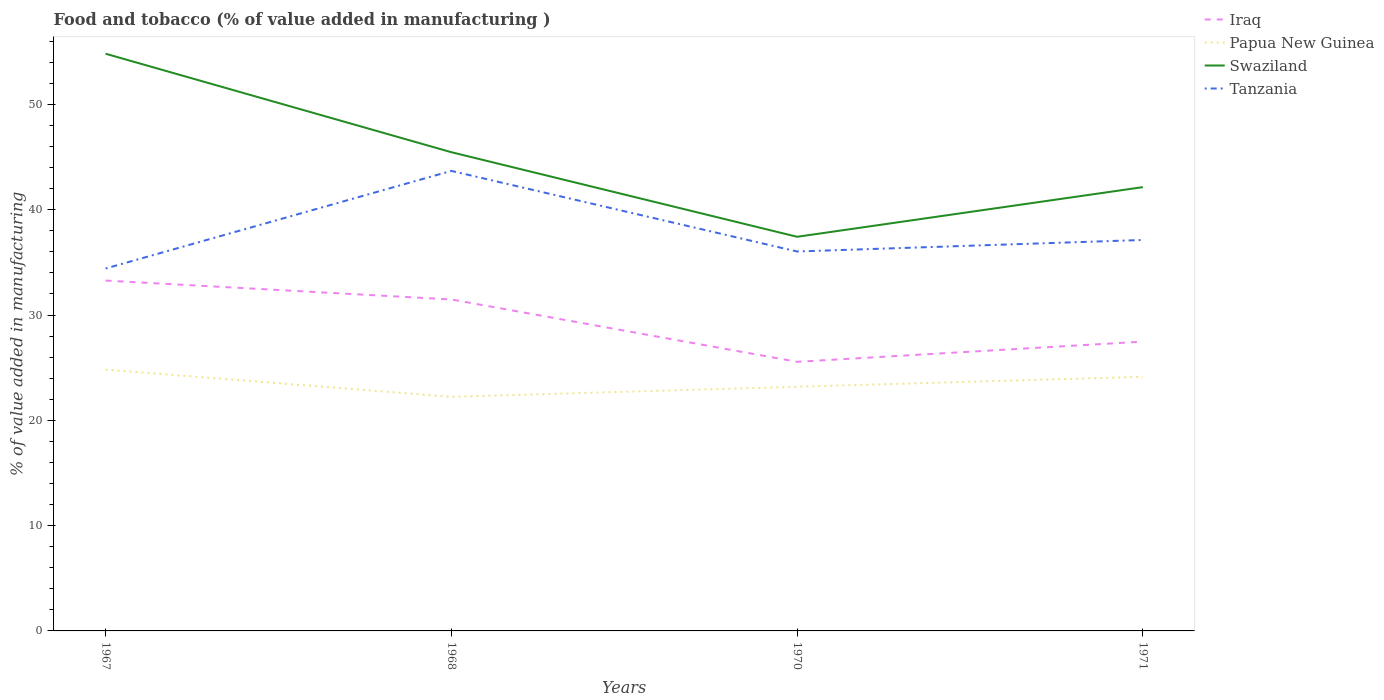How many different coloured lines are there?
Your answer should be compact. 4. Does the line corresponding to Swaziland intersect with the line corresponding to Iraq?
Offer a terse response. No. Across all years, what is the maximum value added in manufacturing food and tobacco in Papua New Guinea?
Provide a succinct answer. 22.23. What is the total value added in manufacturing food and tobacco in Papua New Guinea in the graph?
Your answer should be very brief. -0.96. What is the difference between the highest and the second highest value added in manufacturing food and tobacco in Swaziland?
Provide a short and direct response. 17.39. How many years are there in the graph?
Provide a succinct answer. 4. Are the values on the major ticks of Y-axis written in scientific E-notation?
Your response must be concise. No. Where does the legend appear in the graph?
Provide a succinct answer. Top right. How are the legend labels stacked?
Your answer should be compact. Vertical. What is the title of the graph?
Offer a terse response. Food and tobacco (% of value added in manufacturing ). Does "Puerto Rico" appear as one of the legend labels in the graph?
Your response must be concise. No. What is the label or title of the X-axis?
Ensure brevity in your answer.  Years. What is the label or title of the Y-axis?
Ensure brevity in your answer.  % of value added in manufacturing. What is the % of value added in manufacturing in Iraq in 1967?
Your answer should be very brief. 33.27. What is the % of value added in manufacturing of Papua New Guinea in 1967?
Keep it short and to the point. 24.82. What is the % of value added in manufacturing of Swaziland in 1967?
Your response must be concise. 54.82. What is the % of value added in manufacturing of Tanzania in 1967?
Give a very brief answer. 34.42. What is the % of value added in manufacturing of Iraq in 1968?
Offer a very short reply. 31.48. What is the % of value added in manufacturing of Papua New Guinea in 1968?
Give a very brief answer. 22.23. What is the % of value added in manufacturing of Swaziland in 1968?
Make the answer very short. 45.47. What is the % of value added in manufacturing in Tanzania in 1968?
Offer a terse response. 43.69. What is the % of value added in manufacturing of Iraq in 1970?
Your response must be concise. 25.56. What is the % of value added in manufacturing of Papua New Guinea in 1970?
Your answer should be compact. 23.19. What is the % of value added in manufacturing in Swaziland in 1970?
Your answer should be very brief. 37.43. What is the % of value added in manufacturing in Tanzania in 1970?
Your answer should be very brief. 36.04. What is the % of value added in manufacturing in Iraq in 1971?
Your answer should be compact. 27.48. What is the % of value added in manufacturing in Papua New Guinea in 1971?
Ensure brevity in your answer.  24.13. What is the % of value added in manufacturing of Swaziland in 1971?
Make the answer very short. 42.15. What is the % of value added in manufacturing in Tanzania in 1971?
Provide a short and direct response. 37.13. Across all years, what is the maximum % of value added in manufacturing in Iraq?
Make the answer very short. 33.27. Across all years, what is the maximum % of value added in manufacturing of Papua New Guinea?
Your answer should be very brief. 24.82. Across all years, what is the maximum % of value added in manufacturing of Swaziland?
Give a very brief answer. 54.82. Across all years, what is the maximum % of value added in manufacturing in Tanzania?
Provide a short and direct response. 43.69. Across all years, what is the minimum % of value added in manufacturing of Iraq?
Keep it short and to the point. 25.56. Across all years, what is the minimum % of value added in manufacturing of Papua New Guinea?
Your answer should be compact. 22.23. Across all years, what is the minimum % of value added in manufacturing in Swaziland?
Your response must be concise. 37.43. Across all years, what is the minimum % of value added in manufacturing of Tanzania?
Keep it short and to the point. 34.42. What is the total % of value added in manufacturing in Iraq in the graph?
Offer a very short reply. 117.79. What is the total % of value added in manufacturing of Papua New Guinea in the graph?
Provide a succinct answer. 94.37. What is the total % of value added in manufacturing of Swaziland in the graph?
Offer a terse response. 179.86. What is the total % of value added in manufacturing of Tanzania in the graph?
Keep it short and to the point. 151.27. What is the difference between the % of value added in manufacturing of Iraq in 1967 and that in 1968?
Offer a terse response. 1.79. What is the difference between the % of value added in manufacturing in Papua New Guinea in 1967 and that in 1968?
Offer a terse response. 2.59. What is the difference between the % of value added in manufacturing in Swaziland in 1967 and that in 1968?
Your answer should be compact. 9.35. What is the difference between the % of value added in manufacturing of Tanzania in 1967 and that in 1968?
Offer a terse response. -9.27. What is the difference between the % of value added in manufacturing of Iraq in 1967 and that in 1970?
Give a very brief answer. 7.72. What is the difference between the % of value added in manufacturing in Papua New Guinea in 1967 and that in 1970?
Make the answer very short. 1.63. What is the difference between the % of value added in manufacturing in Swaziland in 1967 and that in 1970?
Your response must be concise. 17.39. What is the difference between the % of value added in manufacturing in Tanzania in 1967 and that in 1970?
Give a very brief answer. -1.62. What is the difference between the % of value added in manufacturing in Iraq in 1967 and that in 1971?
Your answer should be very brief. 5.8. What is the difference between the % of value added in manufacturing of Papua New Guinea in 1967 and that in 1971?
Ensure brevity in your answer.  0.68. What is the difference between the % of value added in manufacturing of Swaziland in 1967 and that in 1971?
Offer a terse response. 12.67. What is the difference between the % of value added in manufacturing in Tanzania in 1967 and that in 1971?
Your answer should be very brief. -2.71. What is the difference between the % of value added in manufacturing in Iraq in 1968 and that in 1970?
Give a very brief answer. 5.92. What is the difference between the % of value added in manufacturing of Papua New Guinea in 1968 and that in 1970?
Your answer should be very brief. -0.96. What is the difference between the % of value added in manufacturing of Swaziland in 1968 and that in 1970?
Your answer should be very brief. 8.03. What is the difference between the % of value added in manufacturing of Tanzania in 1968 and that in 1970?
Ensure brevity in your answer.  7.65. What is the difference between the % of value added in manufacturing in Iraq in 1968 and that in 1971?
Provide a succinct answer. 4. What is the difference between the % of value added in manufacturing in Papua New Guinea in 1968 and that in 1971?
Keep it short and to the point. -1.9. What is the difference between the % of value added in manufacturing in Swaziland in 1968 and that in 1971?
Your response must be concise. 3.32. What is the difference between the % of value added in manufacturing in Tanzania in 1968 and that in 1971?
Offer a terse response. 6.56. What is the difference between the % of value added in manufacturing in Iraq in 1970 and that in 1971?
Give a very brief answer. -1.92. What is the difference between the % of value added in manufacturing of Papua New Guinea in 1970 and that in 1971?
Ensure brevity in your answer.  -0.95. What is the difference between the % of value added in manufacturing in Swaziland in 1970 and that in 1971?
Your response must be concise. -4.72. What is the difference between the % of value added in manufacturing of Tanzania in 1970 and that in 1971?
Keep it short and to the point. -1.09. What is the difference between the % of value added in manufacturing in Iraq in 1967 and the % of value added in manufacturing in Papua New Guinea in 1968?
Offer a terse response. 11.04. What is the difference between the % of value added in manufacturing of Iraq in 1967 and the % of value added in manufacturing of Swaziland in 1968?
Give a very brief answer. -12.19. What is the difference between the % of value added in manufacturing of Iraq in 1967 and the % of value added in manufacturing of Tanzania in 1968?
Keep it short and to the point. -10.42. What is the difference between the % of value added in manufacturing of Papua New Guinea in 1967 and the % of value added in manufacturing of Swaziland in 1968?
Give a very brief answer. -20.65. What is the difference between the % of value added in manufacturing in Papua New Guinea in 1967 and the % of value added in manufacturing in Tanzania in 1968?
Give a very brief answer. -18.87. What is the difference between the % of value added in manufacturing in Swaziland in 1967 and the % of value added in manufacturing in Tanzania in 1968?
Make the answer very short. 11.13. What is the difference between the % of value added in manufacturing of Iraq in 1967 and the % of value added in manufacturing of Papua New Guinea in 1970?
Your answer should be compact. 10.08. What is the difference between the % of value added in manufacturing of Iraq in 1967 and the % of value added in manufacturing of Swaziland in 1970?
Give a very brief answer. -4.16. What is the difference between the % of value added in manufacturing in Iraq in 1967 and the % of value added in manufacturing in Tanzania in 1970?
Provide a succinct answer. -2.76. What is the difference between the % of value added in manufacturing of Papua New Guinea in 1967 and the % of value added in manufacturing of Swaziland in 1970?
Give a very brief answer. -12.61. What is the difference between the % of value added in manufacturing of Papua New Guinea in 1967 and the % of value added in manufacturing of Tanzania in 1970?
Provide a succinct answer. -11.22. What is the difference between the % of value added in manufacturing in Swaziland in 1967 and the % of value added in manufacturing in Tanzania in 1970?
Your answer should be compact. 18.78. What is the difference between the % of value added in manufacturing in Iraq in 1967 and the % of value added in manufacturing in Papua New Guinea in 1971?
Your answer should be compact. 9.14. What is the difference between the % of value added in manufacturing in Iraq in 1967 and the % of value added in manufacturing in Swaziland in 1971?
Offer a very short reply. -8.87. What is the difference between the % of value added in manufacturing in Iraq in 1967 and the % of value added in manufacturing in Tanzania in 1971?
Make the answer very short. -3.86. What is the difference between the % of value added in manufacturing of Papua New Guinea in 1967 and the % of value added in manufacturing of Swaziland in 1971?
Your answer should be very brief. -17.33. What is the difference between the % of value added in manufacturing of Papua New Guinea in 1967 and the % of value added in manufacturing of Tanzania in 1971?
Give a very brief answer. -12.31. What is the difference between the % of value added in manufacturing of Swaziland in 1967 and the % of value added in manufacturing of Tanzania in 1971?
Ensure brevity in your answer.  17.69. What is the difference between the % of value added in manufacturing of Iraq in 1968 and the % of value added in manufacturing of Papua New Guinea in 1970?
Your response must be concise. 8.29. What is the difference between the % of value added in manufacturing of Iraq in 1968 and the % of value added in manufacturing of Swaziland in 1970?
Offer a very short reply. -5.95. What is the difference between the % of value added in manufacturing of Iraq in 1968 and the % of value added in manufacturing of Tanzania in 1970?
Your answer should be very brief. -4.56. What is the difference between the % of value added in manufacturing of Papua New Guinea in 1968 and the % of value added in manufacturing of Swaziland in 1970?
Keep it short and to the point. -15.2. What is the difference between the % of value added in manufacturing in Papua New Guinea in 1968 and the % of value added in manufacturing in Tanzania in 1970?
Your response must be concise. -13.8. What is the difference between the % of value added in manufacturing in Swaziland in 1968 and the % of value added in manufacturing in Tanzania in 1970?
Your response must be concise. 9.43. What is the difference between the % of value added in manufacturing of Iraq in 1968 and the % of value added in manufacturing of Papua New Guinea in 1971?
Provide a short and direct response. 7.34. What is the difference between the % of value added in manufacturing in Iraq in 1968 and the % of value added in manufacturing in Swaziland in 1971?
Provide a short and direct response. -10.67. What is the difference between the % of value added in manufacturing of Iraq in 1968 and the % of value added in manufacturing of Tanzania in 1971?
Ensure brevity in your answer.  -5.65. What is the difference between the % of value added in manufacturing of Papua New Guinea in 1968 and the % of value added in manufacturing of Swaziland in 1971?
Your answer should be compact. -19.91. What is the difference between the % of value added in manufacturing of Papua New Guinea in 1968 and the % of value added in manufacturing of Tanzania in 1971?
Your answer should be very brief. -14.9. What is the difference between the % of value added in manufacturing of Swaziland in 1968 and the % of value added in manufacturing of Tanzania in 1971?
Give a very brief answer. 8.34. What is the difference between the % of value added in manufacturing of Iraq in 1970 and the % of value added in manufacturing of Papua New Guinea in 1971?
Your response must be concise. 1.42. What is the difference between the % of value added in manufacturing of Iraq in 1970 and the % of value added in manufacturing of Swaziland in 1971?
Provide a succinct answer. -16.59. What is the difference between the % of value added in manufacturing in Iraq in 1970 and the % of value added in manufacturing in Tanzania in 1971?
Provide a succinct answer. -11.57. What is the difference between the % of value added in manufacturing of Papua New Guinea in 1970 and the % of value added in manufacturing of Swaziland in 1971?
Provide a short and direct response. -18.96. What is the difference between the % of value added in manufacturing in Papua New Guinea in 1970 and the % of value added in manufacturing in Tanzania in 1971?
Make the answer very short. -13.94. What is the difference between the % of value added in manufacturing of Swaziland in 1970 and the % of value added in manufacturing of Tanzania in 1971?
Offer a very short reply. 0.3. What is the average % of value added in manufacturing in Iraq per year?
Offer a very short reply. 29.45. What is the average % of value added in manufacturing in Papua New Guinea per year?
Your answer should be very brief. 23.59. What is the average % of value added in manufacturing in Swaziland per year?
Offer a very short reply. 44.97. What is the average % of value added in manufacturing in Tanzania per year?
Give a very brief answer. 37.82. In the year 1967, what is the difference between the % of value added in manufacturing in Iraq and % of value added in manufacturing in Papua New Guinea?
Your answer should be very brief. 8.46. In the year 1967, what is the difference between the % of value added in manufacturing in Iraq and % of value added in manufacturing in Swaziland?
Your answer should be very brief. -21.54. In the year 1967, what is the difference between the % of value added in manufacturing of Iraq and % of value added in manufacturing of Tanzania?
Your answer should be compact. -1.15. In the year 1967, what is the difference between the % of value added in manufacturing in Papua New Guinea and % of value added in manufacturing in Swaziland?
Your answer should be compact. -30. In the year 1967, what is the difference between the % of value added in manufacturing in Papua New Guinea and % of value added in manufacturing in Tanzania?
Give a very brief answer. -9.6. In the year 1967, what is the difference between the % of value added in manufacturing in Swaziland and % of value added in manufacturing in Tanzania?
Your answer should be compact. 20.4. In the year 1968, what is the difference between the % of value added in manufacturing of Iraq and % of value added in manufacturing of Papua New Guinea?
Your response must be concise. 9.25. In the year 1968, what is the difference between the % of value added in manufacturing in Iraq and % of value added in manufacturing in Swaziland?
Ensure brevity in your answer.  -13.99. In the year 1968, what is the difference between the % of value added in manufacturing of Iraq and % of value added in manufacturing of Tanzania?
Your answer should be very brief. -12.21. In the year 1968, what is the difference between the % of value added in manufacturing in Papua New Guinea and % of value added in manufacturing in Swaziland?
Your answer should be very brief. -23.23. In the year 1968, what is the difference between the % of value added in manufacturing of Papua New Guinea and % of value added in manufacturing of Tanzania?
Your response must be concise. -21.46. In the year 1968, what is the difference between the % of value added in manufacturing of Swaziland and % of value added in manufacturing of Tanzania?
Keep it short and to the point. 1.78. In the year 1970, what is the difference between the % of value added in manufacturing in Iraq and % of value added in manufacturing in Papua New Guinea?
Provide a succinct answer. 2.37. In the year 1970, what is the difference between the % of value added in manufacturing of Iraq and % of value added in manufacturing of Swaziland?
Offer a very short reply. -11.87. In the year 1970, what is the difference between the % of value added in manufacturing in Iraq and % of value added in manufacturing in Tanzania?
Provide a succinct answer. -10.48. In the year 1970, what is the difference between the % of value added in manufacturing in Papua New Guinea and % of value added in manufacturing in Swaziland?
Your answer should be compact. -14.24. In the year 1970, what is the difference between the % of value added in manufacturing in Papua New Guinea and % of value added in manufacturing in Tanzania?
Your response must be concise. -12.85. In the year 1970, what is the difference between the % of value added in manufacturing in Swaziland and % of value added in manufacturing in Tanzania?
Give a very brief answer. 1.4. In the year 1971, what is the difference between the % of value added in manufacturing of Iraq and % of value added in manufacturing of Papua New Guinea?
Offer a terse response. 3.34. In the year 1971, what is the difference between the % of value added in manufacturing in Iraq and % of value added in manufacturing in Swaziland?
Provide a short and direct response. -14.67. In the year 1971, what is the difference between the % of value added in manufacturing in Iraq and % of value added in manufacturing in Tanzania?
Make the answer very short. -9.65. In the year 1971, what is the difference between the % of value added in manufacturing of Papua New Guinea and % of value added in manufacturing of Swaziland?
Ensure brevity in your answer.  -18.01. In the year 1971, what is the difference between the % of value added in manufacturing in Papua New Guinea and % of value added in manufacturing in Tanzania?
Make the answer very short. -12.99. In the year 1971, what is the difference between the % of value added in manufacturing of Swaziland and % of value added in manufacturing of Tanzania?
Make the answer very short. 5.02. What is the ratio of the % of value added in manufacturing of Iraq in 1967 to that in 1968?
Give a very brief answer. 1.06. What is the ratio of the % of value added in manufacturing in Papua New Guinea in 1967 to that in 1968?
Provide a succinct answer. 1.12. What is the ratio of the % of value added in manufacturing in Swaziland in 1967 to that in 1968?
Make the answer very short. 1.21. What is the ratio of the % of value added in manufacturing in Tanzania in 1967 to that in 1968?
Offer a very short reply. 0.79. What is the ratio of the % of value added in manufacturing of Iraq in 1967 to that in 1970?
Offer a terse response. 1.3. What is the ratio of the % of value added in manufacturing in Papua New Guinea in 1967 to that in 1970?
Your response must be concise. 1.07. What is the ratio of the % of value added in manufacturing in Swaziland in 1967 to that in 1970?
Make the answer very short. 1.46. What is the ratio of the % of value added in manufacturing of Tanzania in 1967 to that in 1970?
Keep it short and to the point. 0.96. What is the ratio of the % of value added in manufacturing in Iraq in 1967 to that in 1971?
Offer a terse response. 1.21. What is the ratio of the % of value added in manufacturing of Papua New Guinea in 1967 to that in 1971?
Keep it short and to the point. 1.03. What is the ratio of the % of value added in manufacturing of Swaziland in 1967 to that in 1971?
Your response must be concise. 1.3. What is the ratio of the % of value added in manufacturing in Tanzania in 1967 to that in 1971?
Offer a terse response. 0.93. What is the ratio of the % of value added in manufacturing of Iraq in 1968 to that in 1970?
Your answer should be very brief. 1.23. What is the ratio of the % of value added in manufacturing in Papua New Guinea in 1968 to that in 1970?
Provide a succinct answer. 0.96. What is the ratio of the % of value added in manufacturing in Swaziland in 1968 to that in 1970?
Give a very brief answer. 1.21. What is the ratio of the % of value added in manufacturing of Tanzania in 1968 to that in 1970?
Your response must be concise. 1.21. What is the ratio of the % of value added in manufacturing of Iraq in 1968 to that in 1971?
Give a very brief answer. 1.15. What is the ratio of the % of value added in manufacturing in Papua New Guinea in 1968 to that in 1971?
Offer a very short reply. 0.92. What is the ratio of the % of value added in manufacturing in Swaziland in 1968 to that in 1971?
Offer a very short reply. 1.08. What is the ratio of the % of value added in manufacturing in Tanzania in 1968 to that in 1971?
Offer a very short reply. 1.18. What is the ratio of the % of value added in manufacturing of Iraq in 1970 to that in 1971?
Make the answer very short. 0.93. What is the ratio of the % of value added in manufacturing of Papua New Guinea in 1970 to that in 1971?
Make the answer very short. 0.96. What is the ratio of the % of value added in manufacturing in Swaziland in 1970 to that in 1971?
Offer a terse response. 0.89. What is the ratio of the % of value added in manufacturing of Tanzania in 1970 to that in 1971?
Ensure brevity in your answer.  0.97. What is the difference between the highest and the second highest % of value added in manufacturing of Iraq?
Your answer should be very brief. 1.79. What is the difference between the highest and the second highest % of value added in manufacturing of Papua New Guinea?
Keep it short and to the point. 0.68. What is the difference between the highest and the second highest % of value added in manufacturing of Swaziland?
Your answer should be compact. 9.35. What is the difference between the highest and the second highest % of value added in manufacturing in Tanzania?
Provide a short and direct response. 6.56. What is the difference between the highest and the lowest % of value added in manufacturing of Iraq?
Offer a very short reply. 7.72. What is the difference between the highest and the lowest % of value added in manufacturing of Papua New Guinea?
Keep it short and to the point. 2.59. What is the difference between the highest and the lowest % of value added in manufacturing of Swaziland?
Make the answer very short. 17.39. What is the difference between the highest and the lowest % of value added in manufacturing of Tanzania?
Keep it short and to the point. 9.27. 